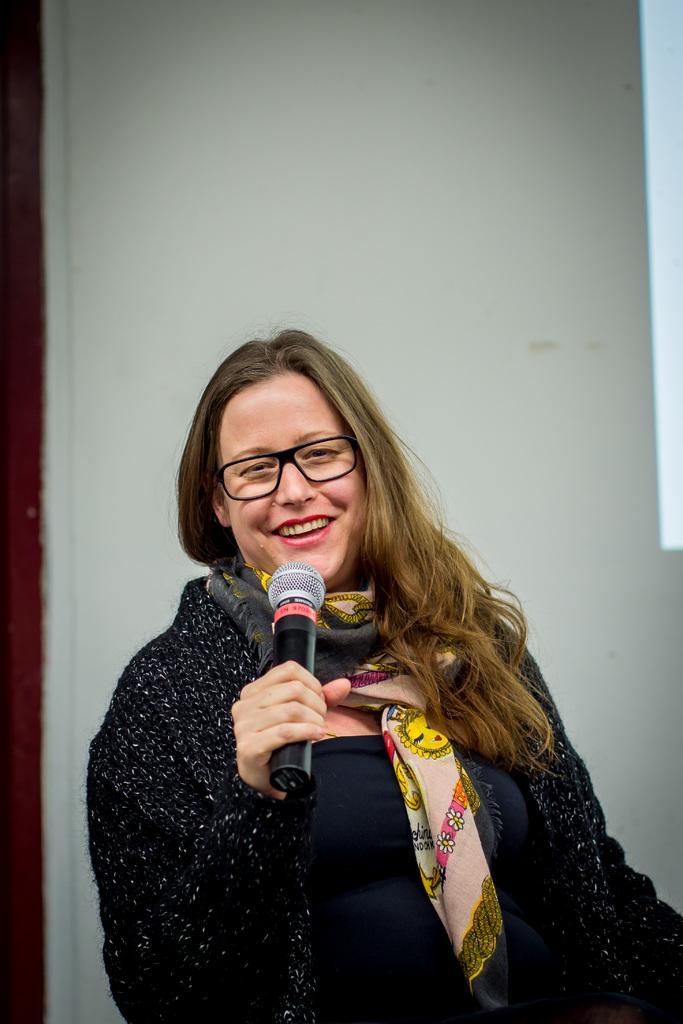Could you give a brief overview of what you see in this image? a person is standing holding a microphone. behind her there is a wall. 